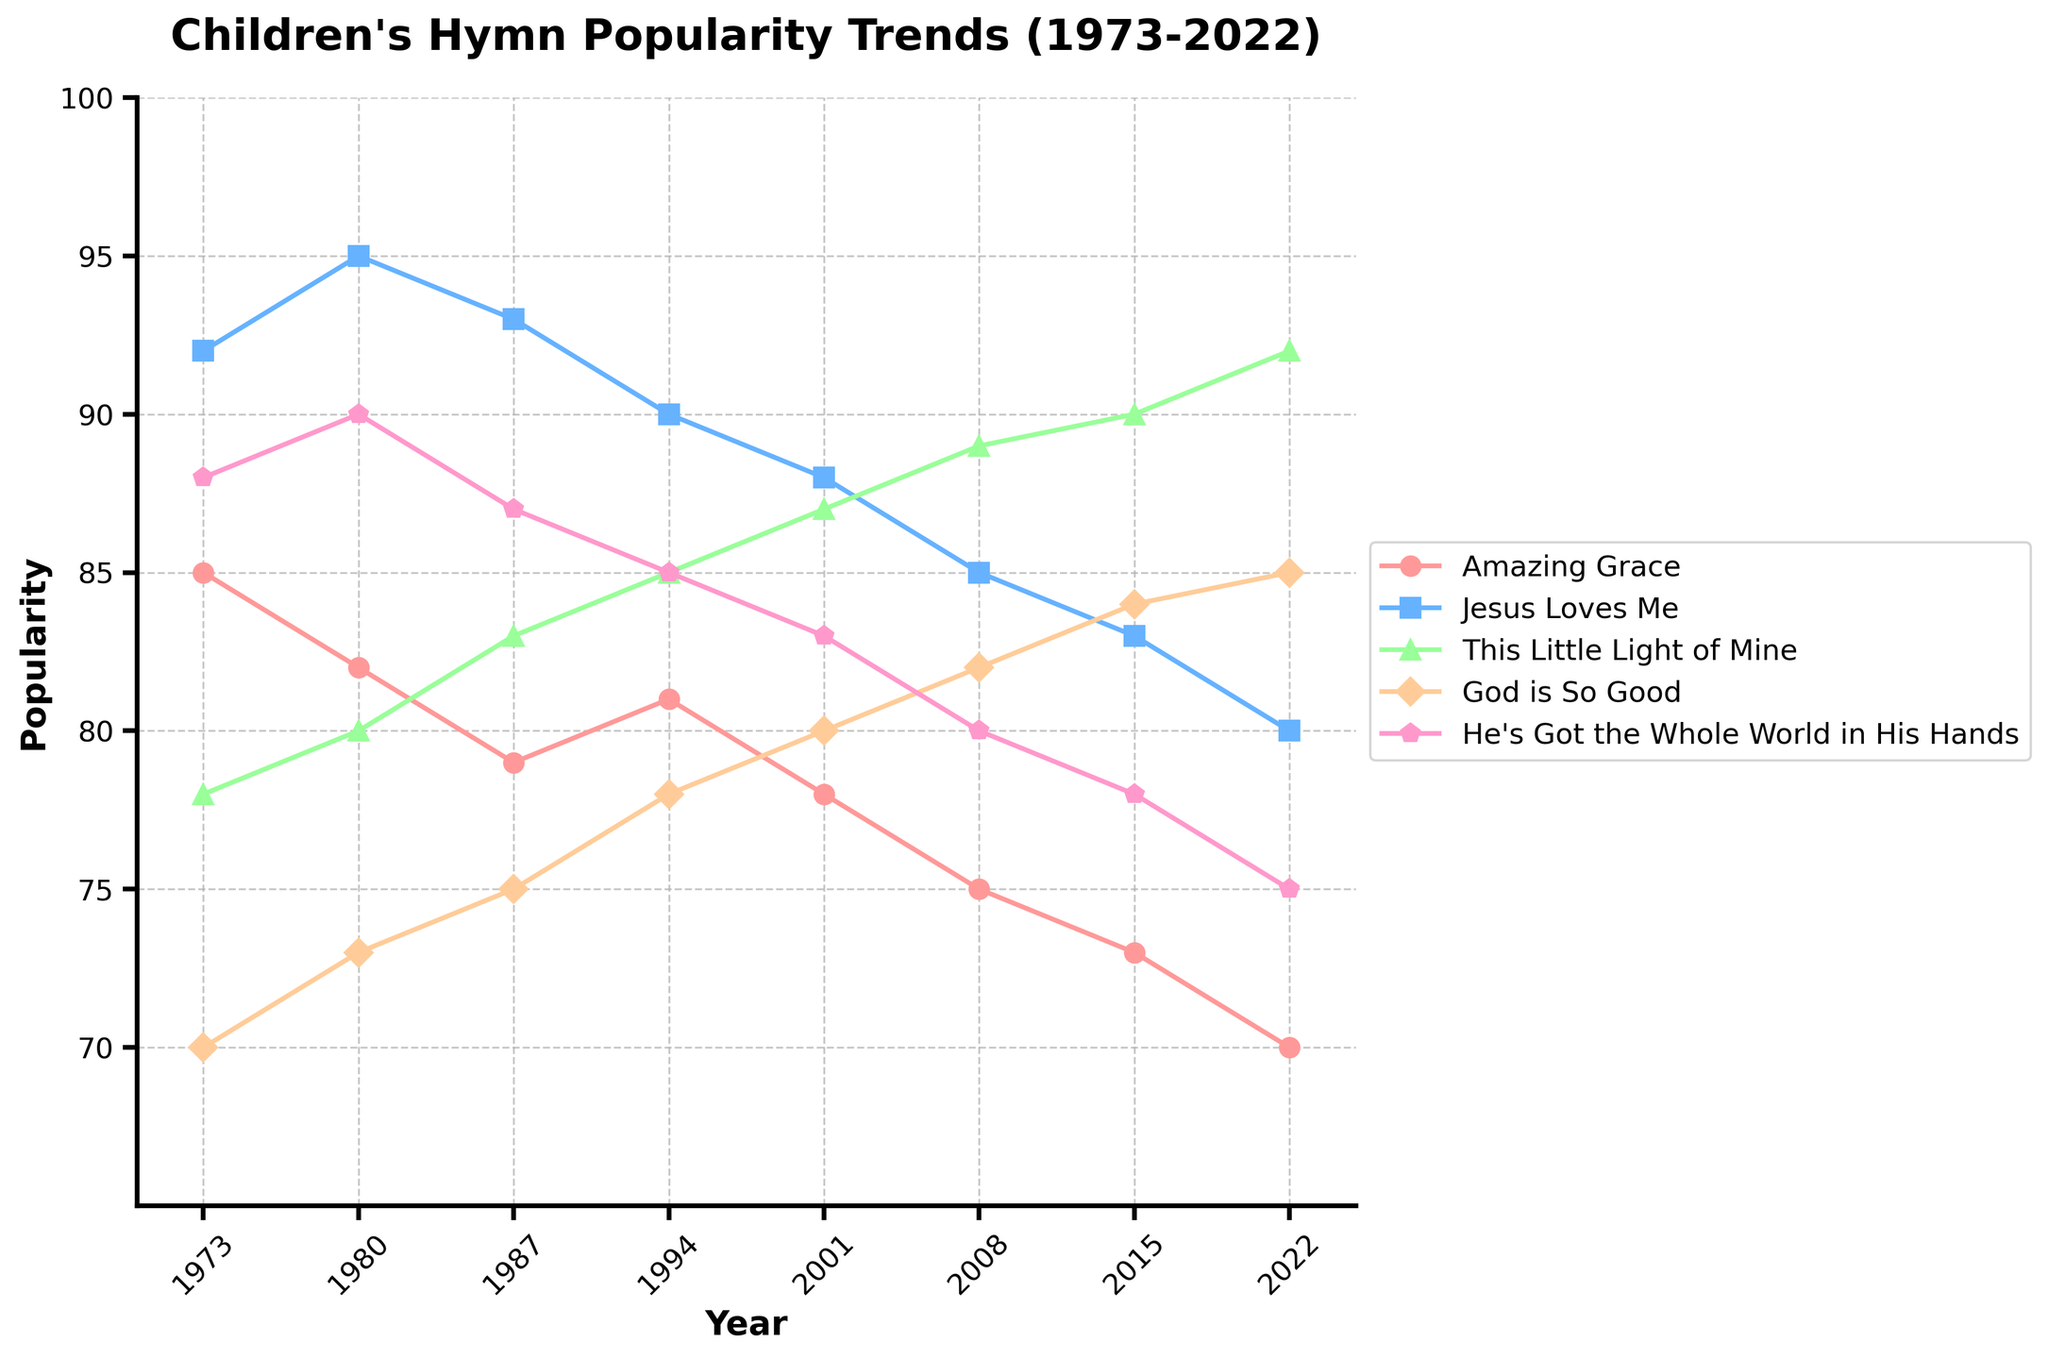Which hymn had the highest popularity in 1973? To answer the question, identify the highest value among the popularity scores in 1973. The values are: Amazing Grace (85), Jesus Loves Me (92), This Little Light of Mine (78), God is So Good (70), He's Got the Whole World in His Hands (88). The highest value is 92, which corresponds to Jesus Loves Me.
Answer: Jesus Loves Me How did the popularity of "Amazing Grace" change from 1973 to 2022? To answer, find the difference between the popularity of "Amazing Grace" in 1973 and 2022. The values are: 1973 (85) and 2022 (70). The difference is 85 - 70 = 15, indicating a decline.
Answer: Decreased by 15 Which hymn had the lowest popularity in 2015? To find the lowest popularity in 2015, compare the values: Amazing Grace (73), Jesus Loves Me (83), This Little Light of Mine (90), God is So Good (84), He's Got the Whole World in His Hands (78). The lowest value is 73, which corresponds to Amazing Grace.
Answer: Amazing Grace Between 1980 and 2008, which hymn shows the most consistent trend? To determine consistency, examine the changes in popularity for each hymn between 1980 and 2008. Amazing Grace fluctuates from 82 to 75, Jesus Loves Me decreases by 10 points, This Little Light of Mine consistently increases, God is So Good steadily increases, and He's Got the Whole World in His Hands shows a slight decline. This Little Light of Mine shows the most consistent increasing trend.
Answer: This Little Light of Mine What is the average popularity of "God is So Good" over the 50 years? To find the average, sum the popularity values of "God is So Good" across all years and then divide by the number of years: (70 + 73 + 75 + 78 + 80 + 82 + 84 + 85) / 8 = 637 / 8 = 79.625.
Answer: 79.625 Which two hymns had nearly identical popularity trends between 2001 and 2022? Locate the popularity values of all hymns from 2001 to 2022 and check for similar trends. God is So Good and He's Got the Whole World in His Hands display similar incremental increases without sudden spikes.
Answer: God is So Good and He's Got the Whole World in His Hands What is the total change in popularity for "This Little Light of Mine" from 1973 to 2022? Calculate the difference from 2022 to 1973: 92 - 78 = 14.
Answer: Increased by 14 In 2022, which hymn had the highest popularity and what was the value? Inspect the values for 2022: Amazing Grace (70), Jesus Loves Me (80), This Little Light of Mine (92), God is So Good (85), He's Got the Whole World in His Hands (75). The highest value is 92, corresponding to This Little Light of Mine.
Answer: This Little Light of Mine with a value of 92 Which hymn's popularity experienced the largest decline from its highest peak over the years? Identify the highest peak for each hymn and its lowest point thereafter. Amazing Grace peaks at 85 in 1973, drops to 70, yielding a decline of 15. Jesus Loves Me peaks at 95, drops to 80 for a decline of 15. This Little Light of Mine peaks at 92, no drop. God is So Good peaks at 85, drops to 70 for 15. He's Got the Whole World in His Hands peaks at 90, drops to 75 for a decline of 15. The declines are equal, so no hymn experienced the largest drop alone.
Answer: All equal with a decline of 15 